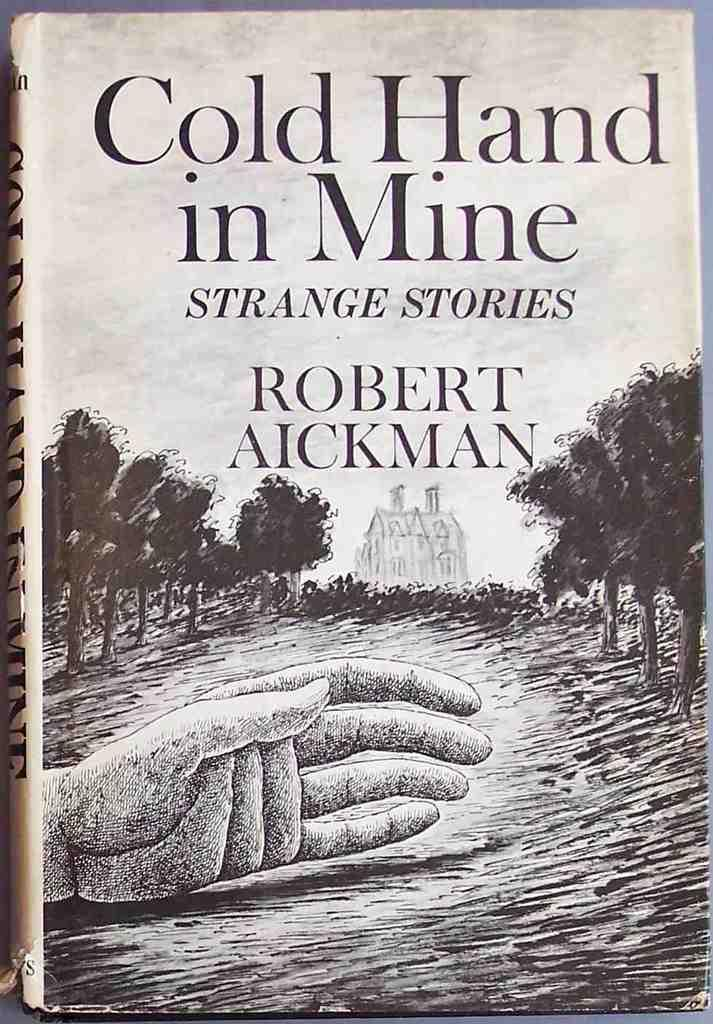<image>
Create a compact narrative representing the image presented. Book titled Cold Hand in Mine showing a house and some trees on the cover. 